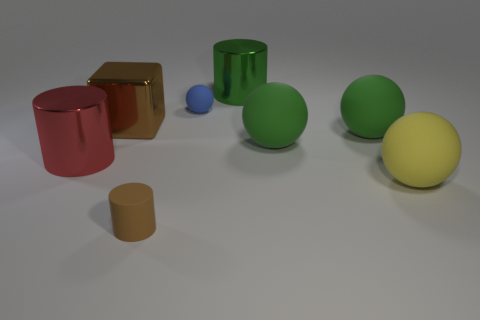The yellow object that is made of the same material as the blue sphere is what shape?
Make the answer very short. Sphere. Do the small thing that is in front of the yellow sphere and the red shiny thing have the same shape?
Ensure brevity in your answer.  Yes. What shape is the small object behind the red object?
Provide a succinct answer. Sphere. What is the shape of the thing that is the same color as the metal block?
Offer a terse response. Cylinder. What number of blocks are the same size as the red object?
Your response must be concise. 1. What color is the small rubber cylinder?
Your answer should be compact. Brown. There is a tiny cylinder; does it have the same color as the metallic cylinder that is right of the large shiny cube?
Give a very brief answer. No. The blue sphere that is the same material as the yellow sphere is what size?
Your response must be concise. Small. Is there a matte ball that has the same color as the metallic cube?
Provide a short and direct response. No. How many objects are either big metal things to the left of the blue matte thing or spheres?
Your response must be concise. 6. 